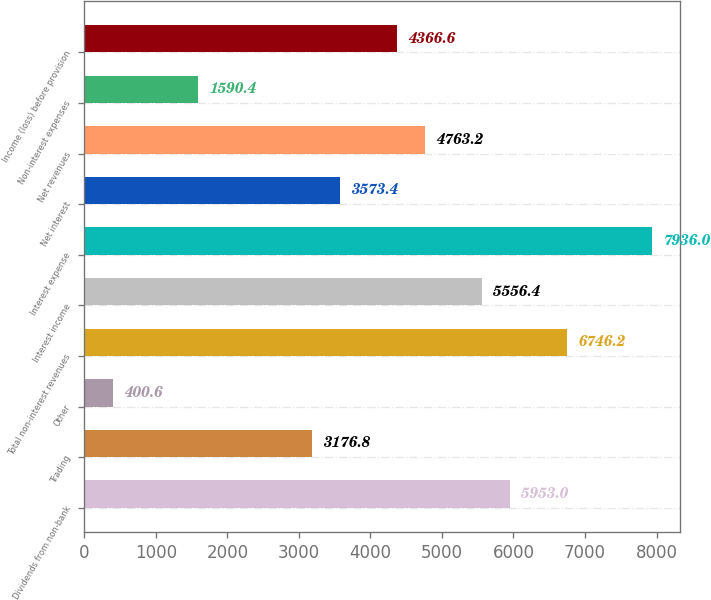<chart> <loc_0><loc_0><loc_500><loc_500><bar_chart><fcel>Dividends from non-bank<fcel>Trading<fcel>Other<fcel>Total non-interest revenues<fcel>Interest income<fcel>Interest expense<fcel>Net interest<fcel>Net revenues<fcel>Non-interest expenses<fcel>Income (loss) before provision<nl><fcel>5953<fcel>3176.8<fcel>400.6<fcel>6746.2<fcel>5556.4<fcel>7936<fcel>3573.4<fcel>4763.2<fcel>1590.4<fcel>4366.6<nl></chart> 